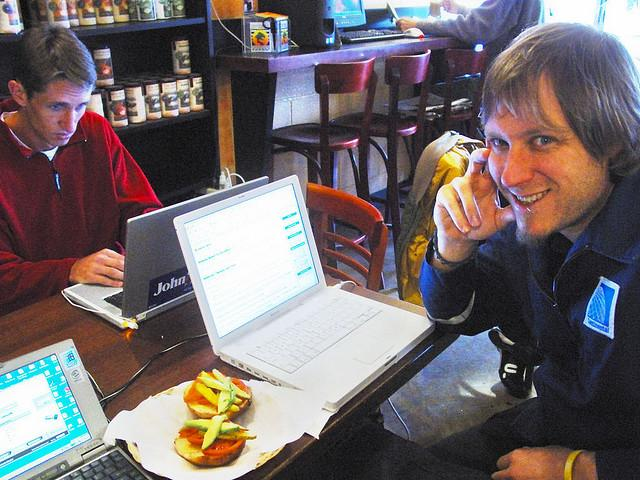What are the green items on top of the tomatoes on the man's sandwich?

Choices:
A) relish
B) avocados
C) lettuce
D) pickles avocados 